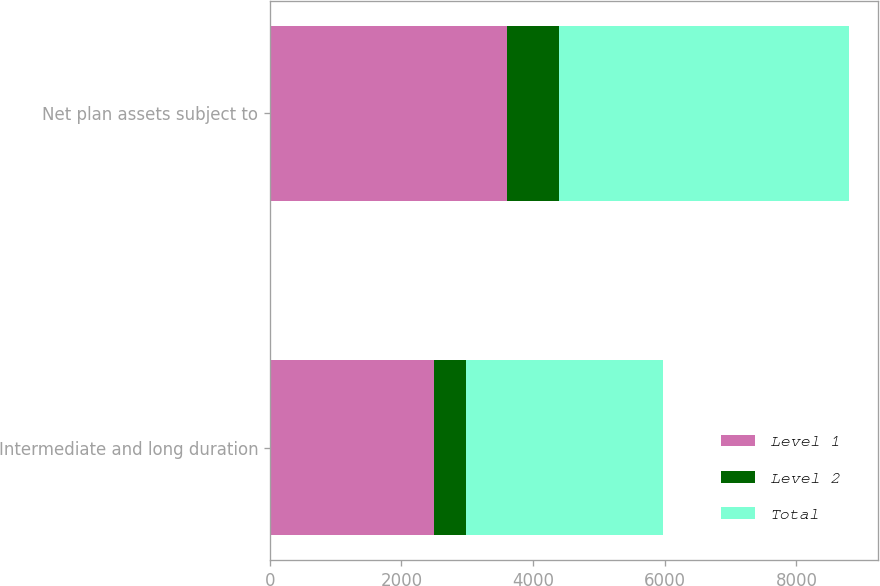Convert chart to OTSL. <chart><loc_0><loc_0><loc_500><loc_500><stacked_bar_chart><ecel><fcel>Intermediate and long duration<fcel>Net plan assets subject to<nl><fcel>Level 1<fcel>2496<fcel>3606<nl><fcel>Level 2<fcel>487<fcel>794<nl><fcel>Total<fcel>2983<fcel>4400<nl></chart> 